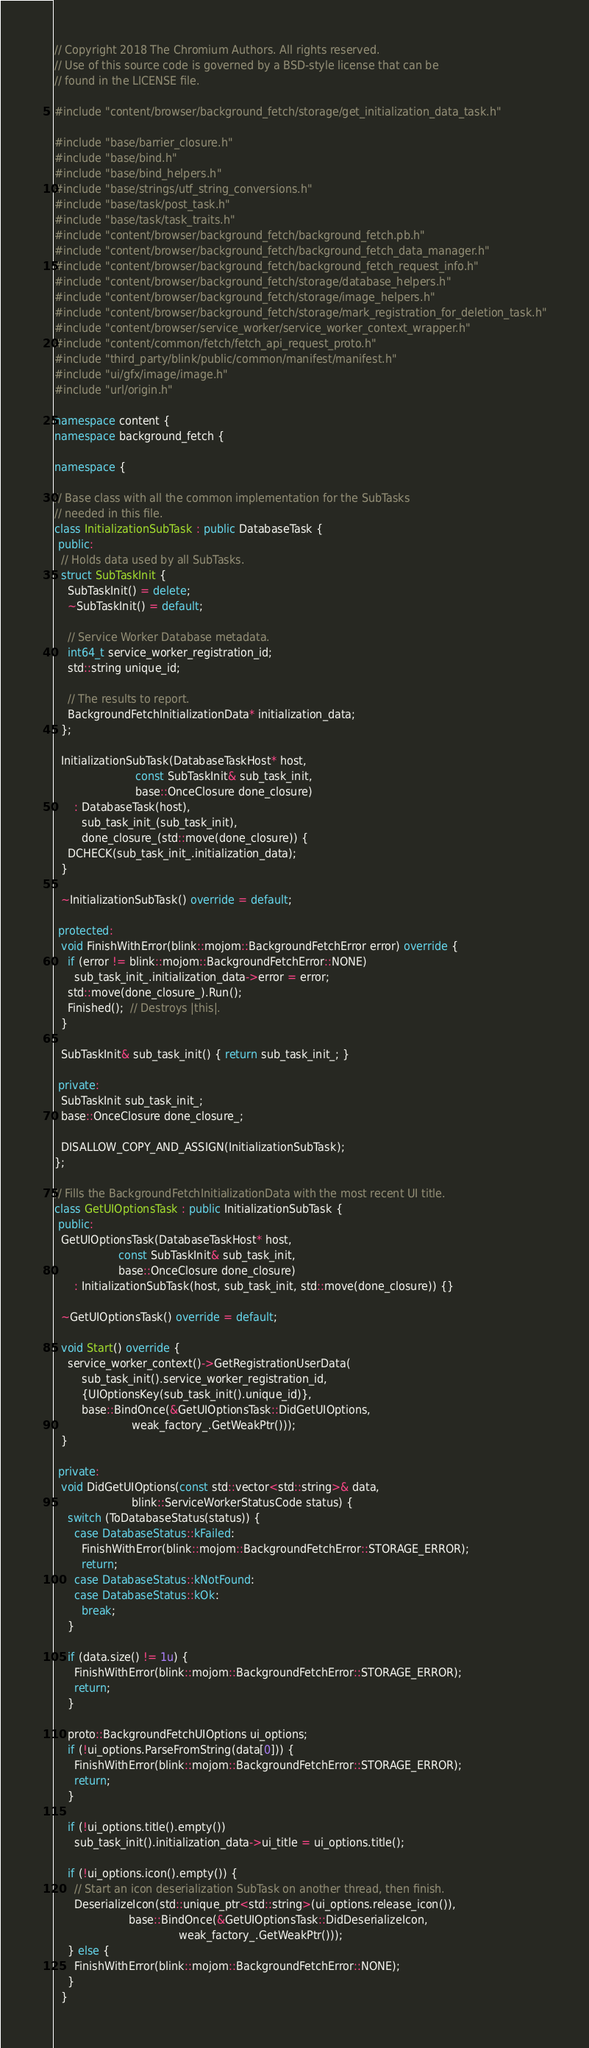Convert code to text. <code><loc_0><loc_0><loc_500><loc_500><_C++_>// Copyright 2018 The Chromium Authors. All rights reserved.
// Use of this source code is governed by a BSD-style license that can be
// found in the LICENSE file.

#include "content/browser/background_fetch/storage/get_initialization_data_task.h"

#include "base/barrier_closure.h"
#include "base/bind.h"
#include "base/bind_helpers.h"
#include "base/strings/utf_string_conversions.h"
#include "base/task/post_task.h"
#include "base/task/task_traits.h"
#include "content/browser/background_fetch/background_fetch.pb.h"
#include "content/browser/background_fetch/background_fetch_data_manager.h"
#include "content/browser/background_fetch/background_fetch_request_info.h"
#include "content/browser/background_fetch/storage/database_helpers.h"
#include "content/browser/background_fetch/storage/image_helpers.h"
#include "content/browser/background_fetch/storage/mark_registration_for_deletion_task.h"
#include "content/browser/service_worker/service_worker_context_wrapper.h"
#include "content/common/fetch/fetch_api_request_proto.h"
#include "third_party/blink/public/common/manifest/manifest.h"
#include "ui/gfx/image/image.h"
#include "url/origin.h"

namespace content {
namespace background_fetch {

namespace {

// Base class with all the common implementation for the SubTasks
// needed in this file.
class InitializationSubTask : public DatabaseTask {
 public:
  // Holds data used by all SubTasks.
  struct SubTaskInit {
    SubTaskInit() = delete;
    ~SubTaskInit() = default;

    // Service Worker Database metadata.
    int64_t service_worker_registration_id;
    std::string unique_id;

    // The results to report.
    BackgroundFetchInitializationData* initialization_data;
  };

  InitializationSubTask(DatabaseTaskHost* host,
                        const SubTaskInit& sub_task_init,
                        base::OnceClosure done_closure)
      : DatabaseTask(host),
        sub_task_init_(sub_task_init),
        done_closure_(std::move(done_closure)) {
    DCHECK(sub_task_init_.initialization_data);
  }

  ~InitializationSubTask() override = default;

 protected:
  void FinishWithError(blink::mojom::BackgroundFetchError error) override {
    if (error != blink::mojom::BackgroundFetchError::NONE)
      sub_task_init_.initialization_data->error = error;
    std::move(done_closure_).Run();
    Finished();  // Destroys |this|.
  }

  SubTaskInit& sub_task_init() { return sub_task_init_; }

 private:
  SubTaskInit sub_task_init_;
  base::OnceClosure done_closure_;

  DISALLOW_COPY_AND_ASSIGN(InitializationSubTask);
};

// Fills the BackgroundFetchInitializationData with the most recent UI title.
class GetUIOptionsTask : public InitializationSubTask {
 public:
  GetUIOptionsTask(DatabaseTaskHost* host,
                   const SubTaskInit& sub_task_init,
                   base::OnceClosure done_closure)
      : InitializationSubTask(host, sub_task_init, std::move(done_closure)) {}

  ~GetUIOptionsTask() override = default;

  void Start() override {
    service_worker_context()->GetRegistrationUserData(
        sub_task_init().service_worker_registration_id,
        {UIOptionsKey(sub_task_init().unique_id)},
        base::BindOnce(&GetUIOptionsTask::DidGetUIOptions,
                       weak_factory_.GetWeakPtr()));
  }

 private:
  void DidGetUIOptions(const std::vector<std::string>& data,
                       blink::ServiceWorkerStatusCode status) {
    switch (ToDatabaseStatus(status)) {
      case DatabaseStatus::kFailed:
        FinishWithError(blink::mojom::BackgroundFetchError::STORAGE_ERROR);
        return;
      case DatabaseStatus::kNotFound:
      case DatabaseStatus::kOk:
        break;
    }

    if (data.size() != 1u) {
      FinishWithError(blink::mojom::BackgroundFetchError::STORAGE_ERROR);
      return;
    }

    proto::BackgroundFetchUIOptions ui_options;
    if (!ui_options.ParseFromString(data[0])) {
      FinishWithError(blink::mojom::BackgroundFetchError::STORAGE_ERROR);
      return;
    }

    if (!ui_options.title().empty())
      sub_task_init().initialization_data->ui_title = ui_options.title();

    if (!ui_options.icon().empty()) {
      // Start an icon deserialization SubTask on another thread, then finish.
      DeserializeIcon(std::unique_ptr<std::string>(ui_options.release_icon()),
                      base::BindOnce(&GetUIOptionsTask::DidDeserializeIcon,
                                     weak_factory_.GetWeakPtr()));
    } else {
      FinishWithError(blink::mojom::BackgroundFetchError::NONE);
    }
  }
</code> 